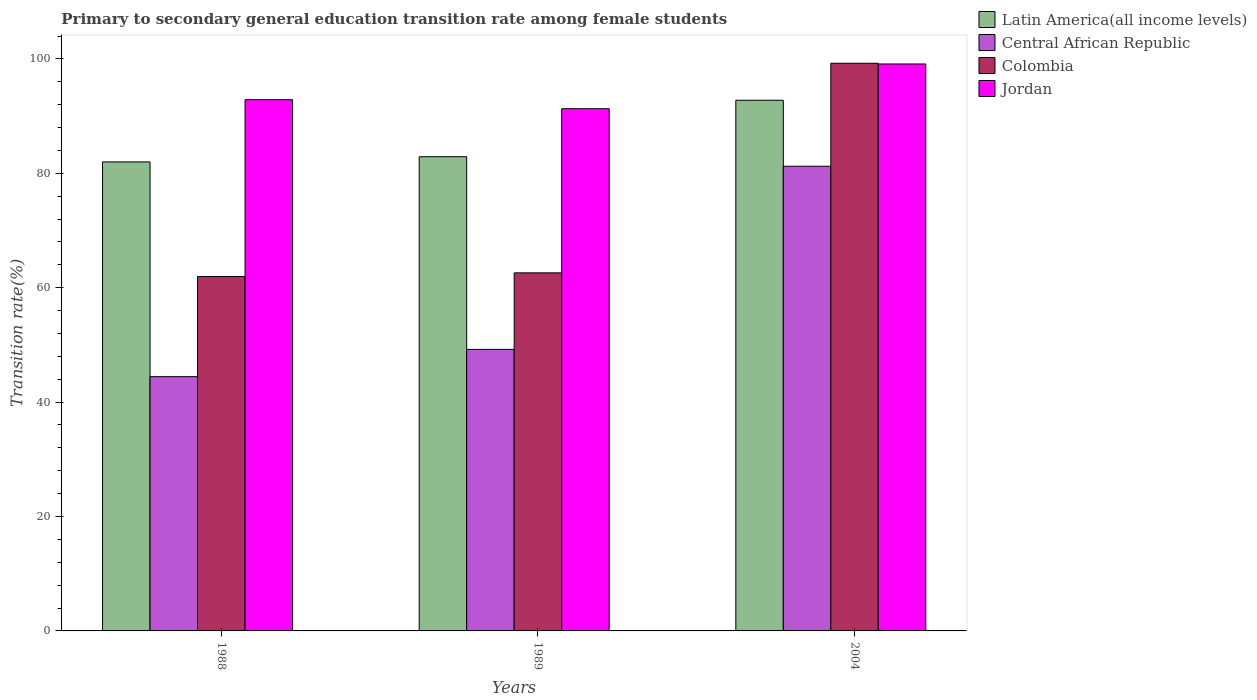How many groups of bars are there?
Provide a short and direct response. 3. Are the number of bars per tick equal to the number of legend labels?
Your answer should be very brief. Yes. How many bars are there on the 1st tick from the left?
Offer a very short reply. 4. What is the transition rate in Colombia in 1989?
Keep it short and to the point. 62.6. Across all years, what is the maximum transition rate in Central African Republic?
Offer a very short reply. 81.23. Across all years, what is the minimum transition rate in Latin America(all income levels)?
Offer a very short reply. 81.99. In which year was the transition rate in Jordan maximum?
Provide a short and direct response. 2004. What is the total transition rate in Jordan in the graph?
Give a very brief answer. 283.27. What is the difference between the transition rate in Jordan in 1989 and that in 2004?
Provide a succinct answer. -7.82. What is the difference between the transition rate in Latin America(all income levels) in 1988 and the transition rate in Central African Republic in 2004?
Provide a succinct answer. 0.76. What is the average transition rate in Jordan per year?
Offer a very short reply. 94.42. In the year 1988, what is the difference between the transition rate in Central African Republic and transition rate in Latin America(all income levels)?
Offer a terse response. -37.54. In how many years, is the transition rate in Latin America(all income levels) greater than 52 %?
Offer a terse response. 3. What is the ratio of the transition rate in Jordan in 1989 to that in 2004?
Offer a terse response. 0.92. Is the transition rate in Central African Republic in 1988 less than that in 1989?
Your response must be concise. Yes. What is the difference between the highest and the second highest transition rate in Central African Republic?
Offer a terse response. 32.02. What is the difference between the highest and the lowest transition rate in Colombia?
Offer a very short reply. 37.28. In how many years, is the transition rate in Jordan greater than the average transition rate in Jordan taken over all years?
Your response must be concise. 1. Is the sum of the transition rate in Jordan in 1989 and 2004 greater than the maximum transition rate in Colombia across all years?
Provide a short and direct response. Yes. What does the 4th bar from the left in 2004 represents?
Give a very brief answer. Jordan. What does the 3rd bar from the right in 2004 represents?
Your response must be concise. Central African Republic. Is it the case that in every year, the sum of the transition rate in Jordan and transition rate in Central African Republic is greater than the transition rate in Colombia?
Keep it short and to the point. Yes. Are all the bars in the graph horizontal?
Keep it short and to the point. No. How many years are there in the graph?
Provide a short and direct response. 3. What is the difference between two consecutive major ticks on the Y-axis?
Your answer should be compact. 20. Does the graph contain grids?
Your answer should be very brief. No. Where does the legend appear in the graph?
Offer a very short reply. Top right. What is the title of the graph?
Keep it short and to the point. Primary to secondary general education transition rate among female students. What is the label or title of the X-axis?
Give a very brief answer. Years. What is the label or title of the Y-axis?
Offer a terse response. Transition rate(%). What is the Transition rate(%) in Latin America(all income levels) in 1988?
Keep it short and to the point. 81.99. What is the Transition rate(%) in Central African Republic in 1988?
Offer a very short reply. 44.45. What is the Transition rate(%) in Colombia in 1988?
Provide a short and direct response. 61.96. What is the Transition rate(%) of Jordan in 1988?
Offer a terse response. 92.86. What is the Transition rate(%) in Latin America(all income levels) in 1989?
Provide a succinct answer. 82.9. What is the Transition rate(%) of Central African Republic in 1989?
Offer a very short reply. 49.22. What is the Transition rate(%) of Colombia in 1989?
Provide a short and direct response. 62.6. What is the Transition rate(%) of Jordan in 1989?
Provide a succinct answer. 91.29. What is the Transition rate(%) of Latin America(all income levels) in 2004?
Make the answer very short. 92.77. What is the Transition rate(%) of Central African Republic in 2004?
Make the answer very short. 81.23. What is the Transition rate(%) of Colombia in 2004?
Your answer should be very brief. 99.24. What is the Transition rate(%) in Jordan in 2004?
Ensure brevity in your answer.  99.11. Across all years, what is the maximum Transition rate(%) of Latin America(all income levels)?
Give a very brief answer. 92.77. Across all years, what is the maximum Transition rate(%) of Central African Republic?
Provide a succinct answer. 81.23. Across all years, what is the maximum Transition rate(%) in Colombia?
Ensure brevity in your answer.  99.24. Across all years, what is the maximum Transition rate(%) in Jordan?
Give a very brief answer. 99.11. Across all years, what is the minimum Transition rate(%) in Latin America(all income levels)?
Give a very brief answer. 81.99. Across all years, what is the minimum Transition rate(%) of Central African Republic?
Your answer should be compact. 44.45. Across all years, what is the minimum Transition rate(%) in Colombia?
Your response must be concise. 61.96. Across all years, what is the minimum Transition rate(%) of Jordan?
Offer a terse response. 91.29. What is the total Transition rate(%) of Latin America(all income levels) in the graph?
Provide a short and direct response. 257.66. What is the total Transition rate(%) of Central African Republic in the graph?
Provide a short and direct response. 174.9. What is the total Transition rate(%) in Colombia in the graph?
Ensure brevity in your answer.  223.79. What is the total Transition rate(%) of Jordan in the graph?
Offer a terse response. 283.27. What is the difference between the Transition rate(%) in Latin America(all income levels) in 1988 and that in 1989?
Your answer should be very brief. -0.91. What is the difference between the Transition rate(%) of Central African Republic in 1988 and that in 1989?
Provide a short and direct response. -4.77. What is the difference between the Transition rate(%) of Colombia in 1988 and that in 1989?
Offer a terse response. -0.64. What is the difference between the Transition rate(%) of Jordan in 1988 and that in 1989?
Your response must be concise. 1.57. What is the difference between the Transition rate(%) of Latin America(all income levels) in 1988 and that in 2004?
Provide a succinct answer. -10.78. What is the difference between the Transition rate(%) in Central African Republic in 1988 and that in 2004?
Give a very brief answer. -36.79. What is the difference between the Transition rate(%) of Colombia in 1988 and that in 2004?
Your answer should be compact. -37.28. What is the difference between the Transition rate(%) in Jordan in 1988 and that in 2004?
Make the answer very short. -6.25. What is the difference between the Transition rate(%) of Latin America(all income levels) in 1989 and that in 2004?
Provide a succinct answer. -9.87. What is the difference between the Transition rate(%) in Central African Republic in 1989 and that in 2004?
Ensure brevity in your answer.  -32.02. What is the difference between the Transition rate(%) of Colombia in 1989 and that in 2004?
Keep it short and to the point. -36.64. What is the difference between the Transition rate(%) in Jordan in 1989 and that in 2004?
Make the answer very short. -7.82. What is the difference between the Transition rate(%) of Latin America(all income levels) in 1988 and the Transition rate(%) of Central African Republic in 1989?
Provide a short and direct response. 32.77. What is the difference between the Transition rate(%) in Latin America(all income levels) in 1988 and the Transition rate(%) in Colombia in 1989?
Offer a terse response. 19.4. What is the difference between the Transition rate(%) of Latin America(all income levels) in 1988 and the Transition rate(%) of Jordan in 1989?
Provide a succinct answer. -9.3. What is the difference between the Transition rate(%) of Central African Republic in 1988 and the Transition rate(%) of Colombia in 1989?
Provide a short and direct response. -18.15. What is the difference between the Transition rate(%) of Central African Republic in 1988 and the Transition rate(%) of Jordan in 1989?
Give a very brief answer. -46.84. What is the difference between the Transition rate(%) in Colombia in 1988 and the Transition rate(%) in Jordan in 1989?
Offer a very short reply. -29.33. What is the difference between the Transition rate(%) in Latin America(all income levels) in 1988 and the Transition rate(%) in Central African Republic in 2004?
Ensure brevity in your answer.  0.76. What is the difference between the Transition rate(%) of Latin America(all income levels) in 1988 and the Transition rate(%) of Colombia in 2004?
Your response must be concise. -17.25. What is the difference between the Transition rate(%) of Latin America(all income levels) in 1988 and the Transition rate(%) of Jordan in 2004?
Provide a short and direct response. -17.12. What is the difference between the Transition rate(%) in Central African Republic in 1988 and the Transition rate(%) in Colombia in 2004?
Keep it short and to the point. -54.79. What is the difference between the Transition rate(%) of Central African Republic in 1988 and the Transition rate(%) of Jordan in 2004?
Your answer should be compact. -54.66. What is the difference between the Transition rate(%) in Colombia in 1988 and the Transition rate(%) in Jordan in 2004?
Make the answer very short. -37.16. What is the difference between the Transition rate(%) in Latin America(all income levels) in 1989 and the Transition rate(%) in Central African Republic in 2004?
Keep it short and to the point. 1.66. What is the difference between the Transition rate(%) in Latin America(all income levels) in 1989 and the Transition rate(%) in Colombia in 2004?
Provide a short and direct response. -16.34. What is the difference between the Transition rate(%) in Latin America(all income levels) in 1989 and the Transition rate(%) in Jordan in 2004?
Give a very brief answer. -16.22. What is the difference between the Transition rate(%) of Central African Republic in 1989 and the Transition rate(%) of Colombia in 2004?
Provide a short and direct response. -50.02. What is the difference between the Transition rate(%) in Central African Republic in 1989 and the Transition rate(%) in Jordan in 2004?
Make the answer very short. -49.9. What is the difference between the Transition rate(%) of Colombia in 1989 and the Transition rate(%) of Jordan in 2004?
Ensure brevity in your answer.  -36.52. What is the average Transition rate(%) of Latin America(all income levels) per year?
Provide a succinct answer. 85.89. What is the average Transition rate(%) of Central African Republic per year?
Your answer should be compact. 58.3. What is the average Transition rate(%) of Colombia per year?
Your answer should be very brief. 74.6. What is the average Transition rate(%) of Jordan per year?
Ensure brevity in your answer.  94.42. In the year 1988, what is the difference between the Transition rate(%) of Latin America(all income levels) and Transition rate(%) of Central African Republic?
Your response must be concise. 37.54. In the year 1988, what is the difference between the Transition rate(%) of Latin America(all income levels) and Transition rate(%) of Colombia?
Keep it short and to the point. 20.03. In the year 1988, what is the difference between the Transition rate(%) in Latin America(all income levels) and Transition rate(%) in Jordan?
Keep it short and to the point. -10.87. In the year 1988, what is the difference between the Transition rate(%) of Central African Republic and Transition rate(%) of Colombia?
Provide a short and direct response. -17.51. In the year 1988, what is the difference between the Transition rate(%) of Central African Republic and Transition rate(%) of Jordan?
Make the answer very short. -48.42. In the year 1988, what is the difference between the Transition rate(%) in Colombia and Transition rate(%) in Jordan?
Your answer should be very brief. -30.91. In the year 1989, what is the difference between the Transition rate(%) in Latin America(all income levels) and Transition rate(%) in Central African Republic?
Your response must be concise. 33.68. In the year 1989, what is the difference between the Transition rate(%) in Latin America(all income levels) and Transition rate(%) in Colombia?
Provide a succinct answer. 20.3. In the year 1989, what is the difference between the Transition rate(%) of Latin America(all income levels) and Transition rate(%) of Jordan?
Keep it short and to the point. -8.39. In the year 1989, what is the difference between the Transition rate(%) of Central African Republic and Transition rate(%) of Colombia?
Your response must be concise. -13.38. In the year 1989, what is the difference between the Transition rate(%) of Central African Republic and Transition rate(%) of Jordan?
Offer a terse response. -42.07. In the year 1989, what is the difference between the Transition rate(%) in Colombia and Transition rate(%) in Jordan?
Provide a short and direct response. -28.69. In the year 2004, what is the difference between the Transition rate(%) of Latin America(all income levels) and Transition rate(%) of Central African Republic?
Provide a succinct answer. 11.54. In the year 2004, what is the difference between the Transition rate(%) in Latin America(all income levels) and Transition rate(%) in Colombia?
Offer a very short reply. -6.47. In the year 2004, what is the difference between the Transition rate(%) in Latin America(all income levels) and Transition rate(%) in Jordan?
Offer a very short reply. -6.34. In the year 2004, what is the difference between the Transition rate(%) of Central African Republic and Transition rate(%) of Colombia?
Give a very brief answer. -18. In the year 2004, what is the difference between the Transition rate(%) of Central African Republic and Transition rate(%) of Jordan?
Your answer should be very brief. -17.88. In the year 2004, what is the difference between the Transition rate(%) in Colombia and Transition rate(%) in Jordan?
Provide a succinct answer. 0.13. What is the ratio of the Transition rate(%) in Latin America(all income levels) in 1988 to that in 1989?
Offer a very short reply. 0.99. What is the ratio of the Transition rate(%) of Central African Republic in 1988 to that in 1989?
Your response must be concise. 0.9. What is the ratio of the Transition rate(%) in Jordan in 1988 to that in 1989?
Keep it short and to the point. 1.02. What is the ratio of the Transition rate(%) of Latin America(all income levels) in 1988 to that in 2004?
Provide a short and direct response. 0.88. What is the ratio of the Transition rate(%) in Central African Republic in 1988 to that in 2004?
Give a very brief answer. 0.55. What is the ratio of the Transition rate(%) in Colombia in 1988 to that in 2004?
Your answer should be very brief. 0.62. What is the ratio of the Transition rate(%) of Jordan in 1988 to that in 2004?
Provide a short and direct response. 0.94. What is the ratio of the Transition rate(%) of Latin America(all income levels) in 1989 to that in 2004?
Provide a short and direct response. 0.89. What is the ratio of the Transition rate(%) of Central African Republic in 1989 to that in 2004?
Offer a very short reply. 0.61. What is the ratio of the Transition rate(%) of Colombia in 1989 to that in 2004?
Make the answer very short. 0.63. What is the ratio of the Transition rate(%) in Jordan in 1989 to that in 2004?
Your answer should be very brief. 0.92. What is the difference between the highest and the second highest Transition rate(%) in Latin America(all income levels)?
Give a very brief answer. 9.87. What is the difference between the highest and the second highest Transition rate(%) in Central African Republic?
Ensure brevity in your answer.  32.02. What is the difference between the highest and the second highest Transition rate(%) of Colombia?
Your response must be concise. 36.64. What is the difference between the highest and the second highest Transition rate(%) in Jordan?
Give a very brief answer. 6.25. What is the difference between the highest and the lowest Transition rate(%) in Latin America(all income levels)?
Give a very brief answer. 10.78. What is the difference between the highest and the lowest Transition rate(%) of Central African Republic?
Ensure brevity in your answer.  36.79. What is the difference between the highest and the lowest Transition rate(%) of Colombia?
Provide a short and direct response. 37.28. What is the difference between the highest and the lowest Transition rate(%) of Jordan?
Provide a short and direct response. 7.82. 